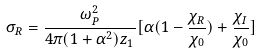<formula> <loc_0><loc_0><loc_500><loc_500>\sigma _ { R } = \frac { \omega _ { P } ^ { 2 } } { 4 \pi ( 1 + \alpha ^ { 2 } ) z _ { 1 } } [ \alpha ( 1 - \frac { \chi _ { R } } { \chi _ { 0 } } ) + \frac { \chi _ { I } } { \chi _ { 0 } } ]</formula> 